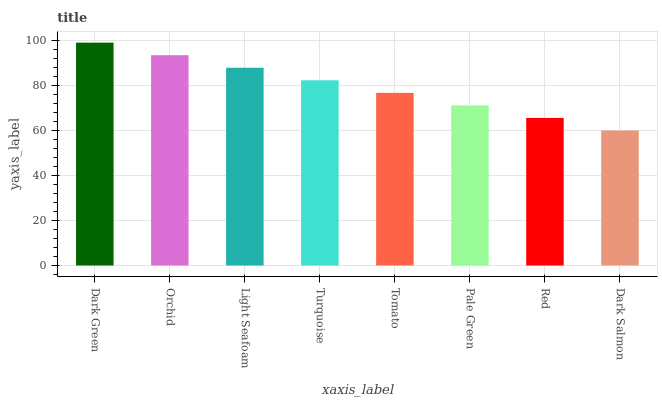Is Orchid the minimum?
Answer yes or no. No. Is Orchid the maximum?
Answer yes or no. No. Is Dark Green greater than Orchid?
Answer yes or no. Yes. Is Orchid less than Dark Green?
Answer yes or no. Yes. Is Orchid greater than Dark Green?
Answer yes or no. No. Is Dark Green less than Orchid?
Answer yes or no. No. Is Turquoise the high median?
Answer yes or no. Yes. Is Tomato the low median?
Answer yes or no. Yes. Is Dark Green the high median?
Answer yes or no. No. Is Dark Green the low median?
Answer yes or no. No. 